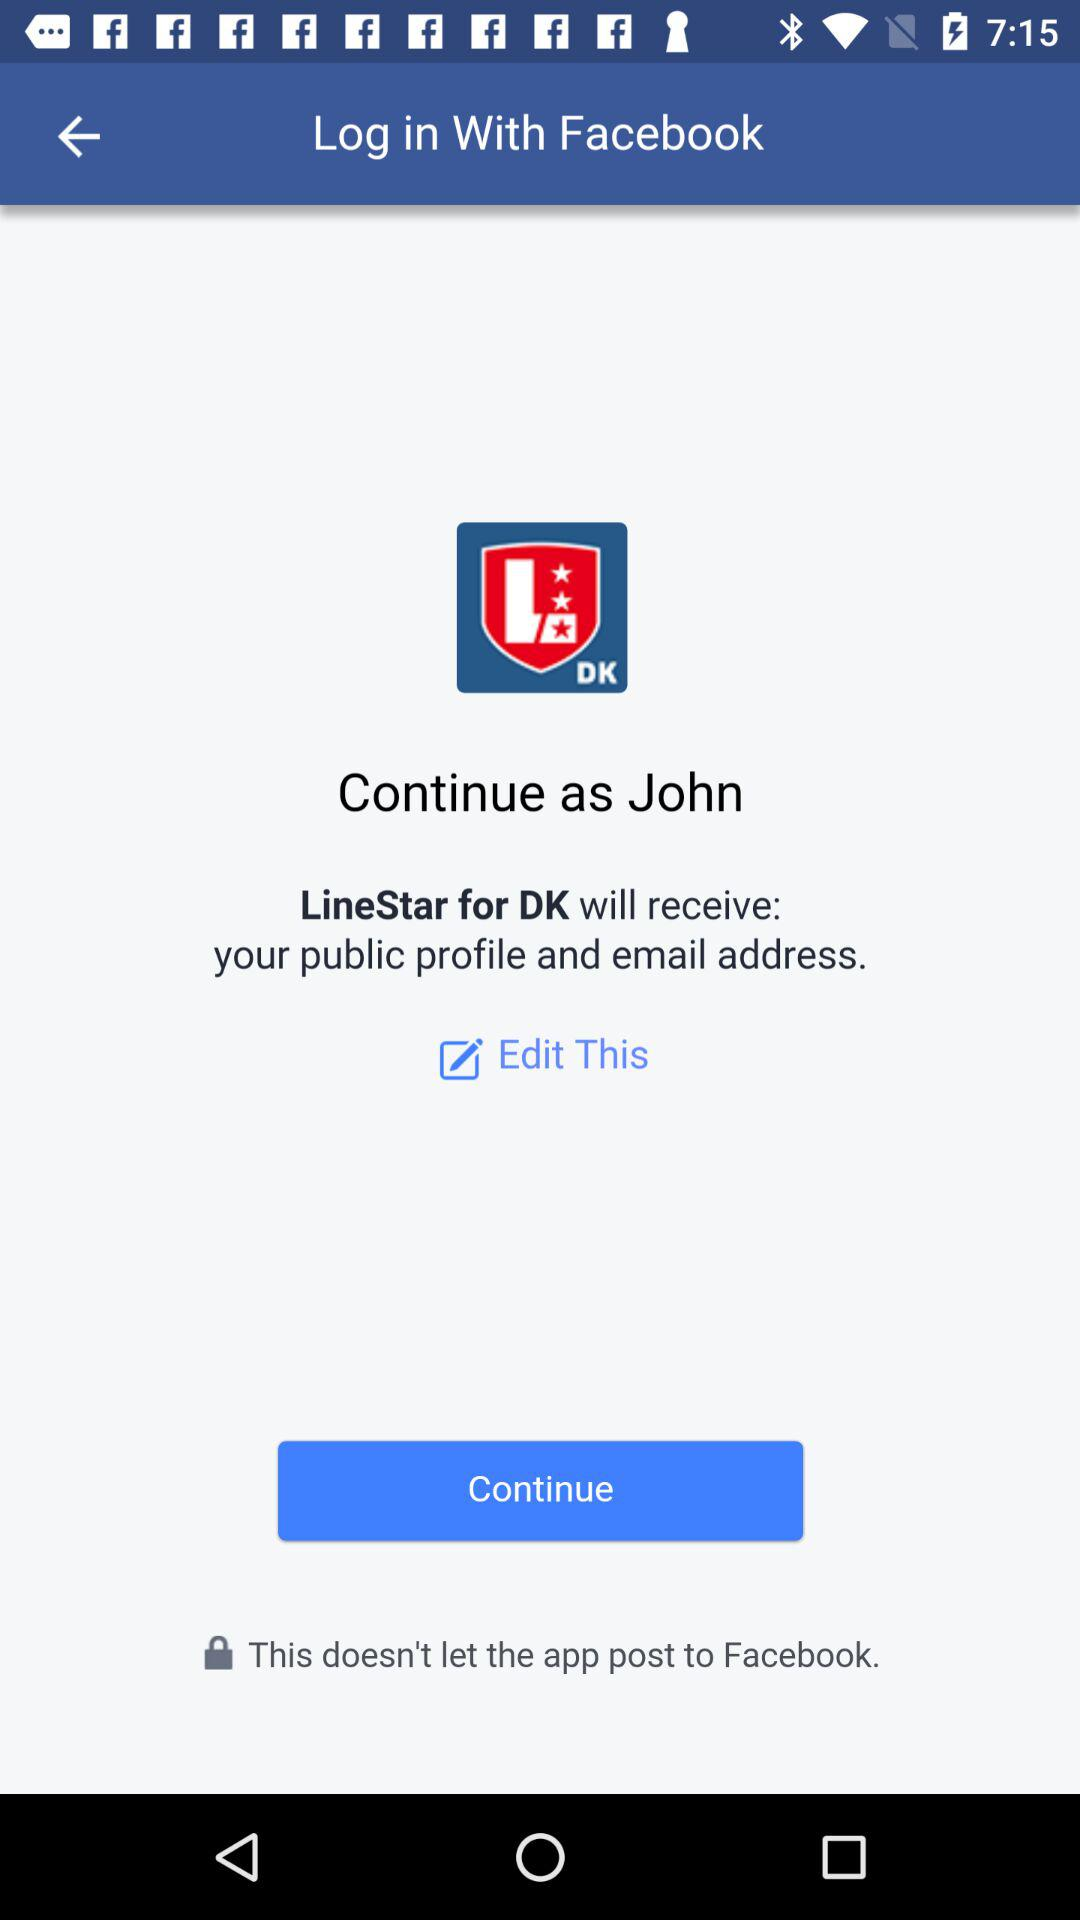What is the user name? The user name is John. 